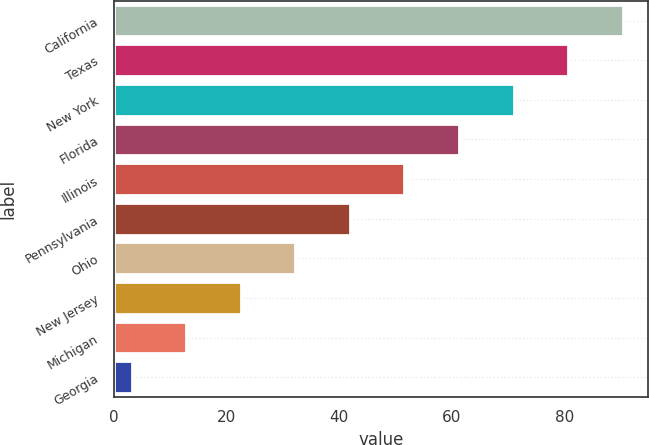Convert chart to OTSL. <chart><loc_0><loc_0><loc_500><loc_500><bar_chart><fcel>California<fcel>Texas<fcel>New York<fcel>Florida<fcel>Illinois<fcel>Pennsylvania<fcel>Ohio<fcel>New Jersey<fcel>Michigan<fcel>Georgia<nl><fcel>90.31<fcel>80.62<fcel>70.93<fcel>61.24<fcel>51.55<fcel>41.86<fcel>32.17<fcel>22.48<fcel>12.79<fcel>3.1<nl></chart> 